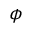<formula> <loc_0><loc_0><loc_500><loc_500>\phi</formula> 